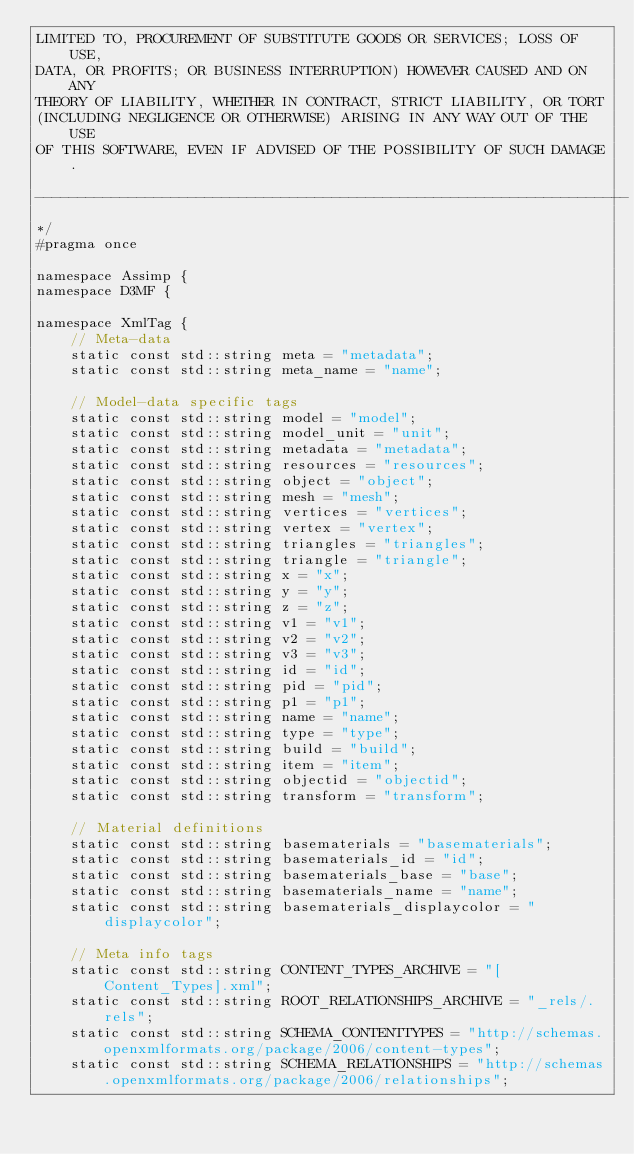<code> <loc_0><loc_0><loc_500><loc_500><_C_>LIMITED TO, PROCUREMENT OF SUBSTITUTE GOODS OR SERVICES; LOSS OF USE,
DATA, OR PROFITS; OR BUSINESS INTERRUPTION) HOWEVER CAUSED AND ON ANY
THEORY OF LIABILITY, WHETHER IN CONTRACT, STRICT LIABILITY, OR TORT
(INCLUDING NEGLIGENCE OR OTHERWISE) ARISING IN ANY WAY OUT OF THE USE
OF THIS SOFTWARE, EVEN IF ADVISED OF THE POSSIBILITY OF SUCH DAMAGE.

----------------------------------------------------------------------
*/
#pragma once

namespace Assimp {
namespace D3MF {

namespace XmlTag {
    // Meta-data
    static const std::string meta = "metadata";
    static const std::string meta_name = "name";

    // Model-data specific tags
    static const std::string model = "model";
    static const std::string model_unit = "unit";
    static const std::string metadata = "metadata";
    static const std::string resources = "resources";
    static const std::string object = "object";
    static const std::string mesh = "mesh";
    static const std::string vertices = "vertices";
    static const std::string vertex = "vertex";
    static const std::string triangles = "triangles";
    static const std::string triangle = "triangle";
    static const std::string x = "x";
    static const std::string y = "y";
    static const std::string z = "z";
    static const std::string v1 = "v1";
    static const std::string v2 = "v2";
    static const std::string v3 = "v3";
    static const std::string id = "id";
    static const std::string pid = "pid";
    static const std::string p1 = "p1";
    static const std::string name = "name";
    static const std::string type = "type";
    static const std::string build = "build";
    static const std::string item = "item";
    static const std::string objectid = "objectid";
    static const std::string transform = "transform";

    // Material definitions
    static const std::string basematerials = "basematerials";
    static const std::string basematerials_id = "id";
    static const std::string basematerials_base = "base";
    static const std::string basematerials_name = "name";
    static const std::string basematerials_displaycolor = "displaycolor";

    // Meta info tags
    static const std::string CONTENT_TYPES_ARCHIVE = "[Content_Types].xml";
    static const std::string ROOT_RELATIONSHIPS_ARCHIVE = "_rels/.rels";
    static const std::string SCHEMA_CONTENTTYPES = "http://schemas.openxmlformats.org/package/2006/content-types";
    static const std::string SCHEMA_RELATIONSHIPS = "http://schemas.openxmlformats.org/package/2006/relationships";</code> 